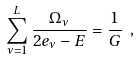Convert formula to latex. <formula><loc_0><loc_0><loc_500><loc_500>\sum _ { \nu = 1 } ^ { L } \frac { \Omega _ { \nu } } { 2 e _ { \nu } - E } = \frac { 1 } { G } \ ,</formula> 